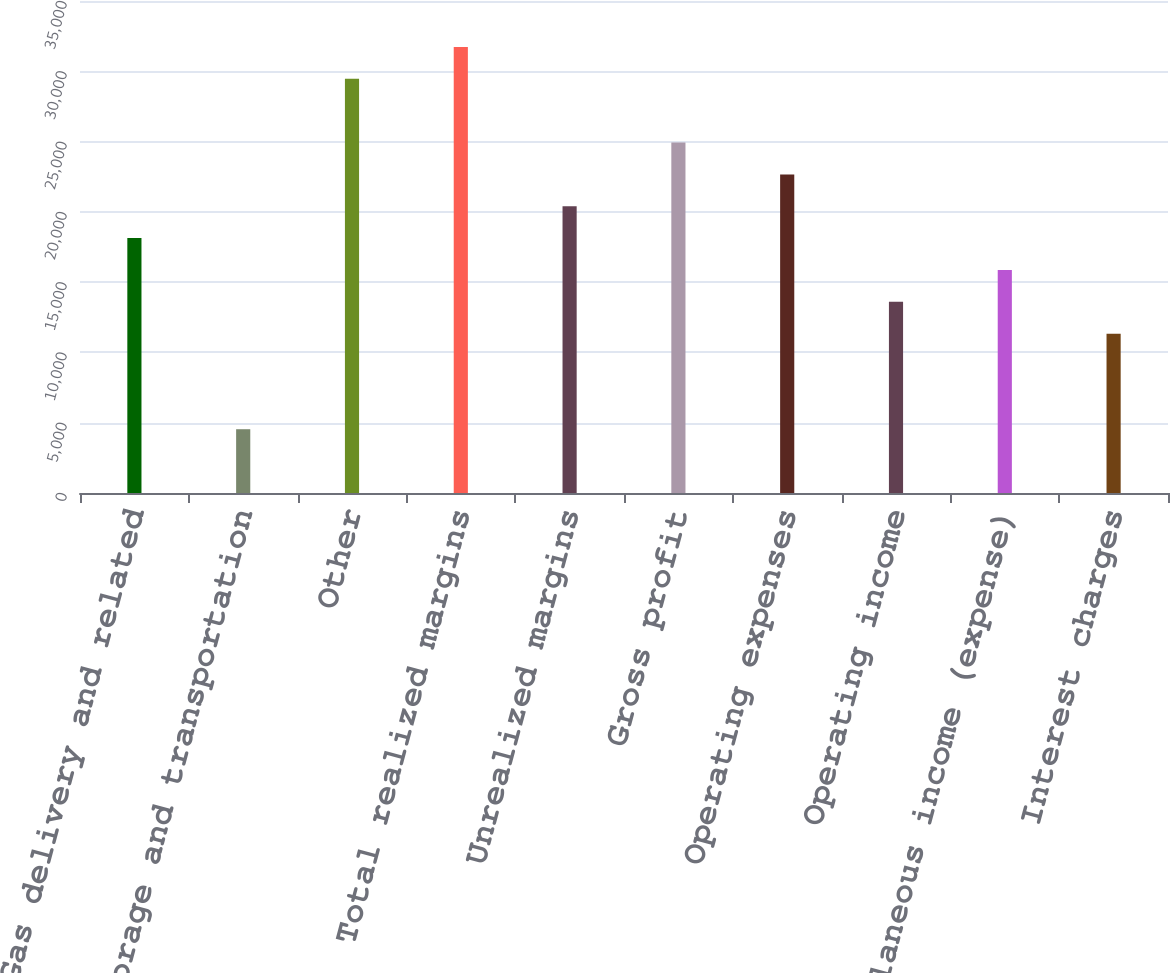Convert chart. <chart><loc_0><loc_0><loc_500><loc_500><bar_chart><fcel>Gas delivery and related<fcel>Storage and transportation<fcel>Other<fcel>Total realized margins<fcel>Unrealized margins<fcel>Gross profit<fcel>Operating expenses<fcel>Operating income<fcel>Miscellaneous income (expense)<fcel>Interest charges<nl><fcel>18132.9<fcel>4536.68<fcel>29463.1<fcel>31729.2<fcel>20399<fcel>24931<fcel>22665<fcel>13600.8<fcel>15866.9<fcel>11334.8<nl></chart> 